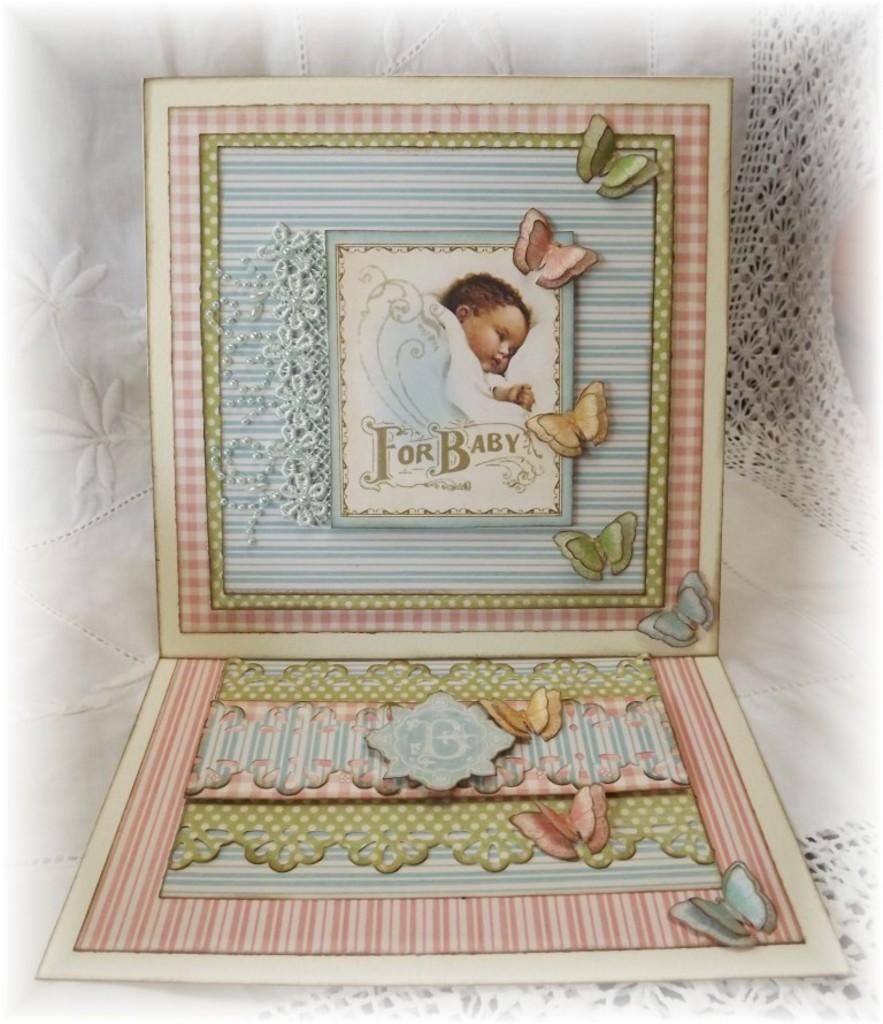<image>
Offer a succinct explanation of the picture presented. Baby card showing a baby and the words "For Baby" on it. 